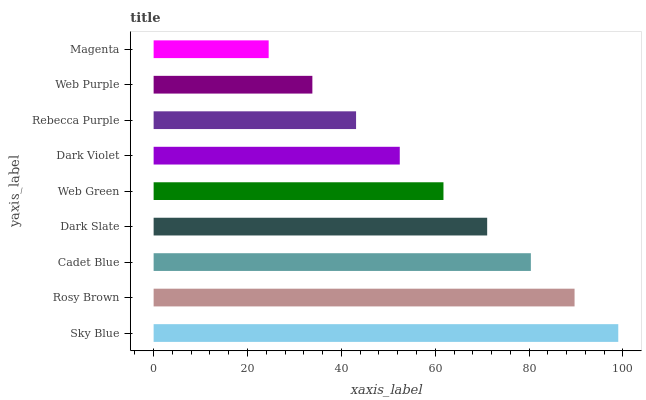Is Magenta the minimum?
Answer yes or no. Yes. Is Sky Blue the maximum?
Answer yes or no. Yes. Is Rosy Brown the minimum?
Answer yes or no. No. Is Rosy Brown the maximum?
Answer yes or no. No. Is Sky Blue greater than Rosy Brown?
Answer yes or no. Yes. Is Rosy Brown less than Sky Blue?
Answer yes or no. Yes. Is Rosy Brown greater than Sky Blue?
Answer yes or no. No. Is Sky Blue less than Rosy Brown?
Answer yes or no. No. Is Web Green the high median?
Answer yes or no. Yes. Is Web Green the low median?
Answer yes or no. Yes. Is Cadet Blue the high median?
Answer yes or no. No. Is Dark Slate the low median?
Answer yes or no. No. 